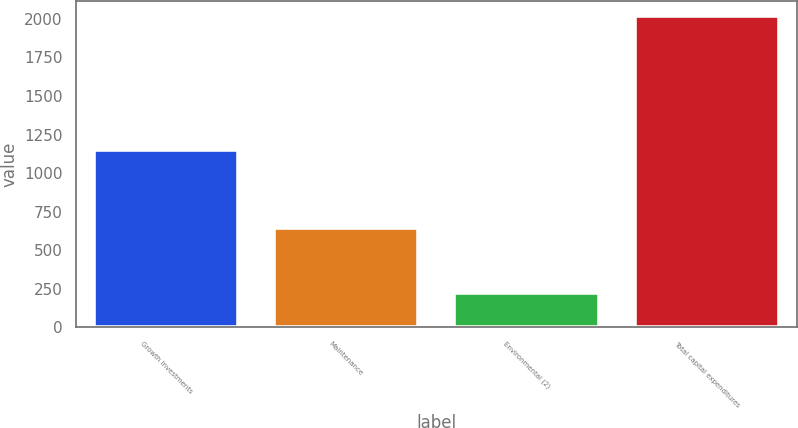<chart> <loc_0><loc_0><loc_500><loc_500><bar_chart><fcel>Growth Investments<fcel>Maintenance<fcel>Environmental (2)<fcel>Total capital expenditures<nl><fcel>1151<fcel>645<fcel>220<fcel>2016<nl></chart> 